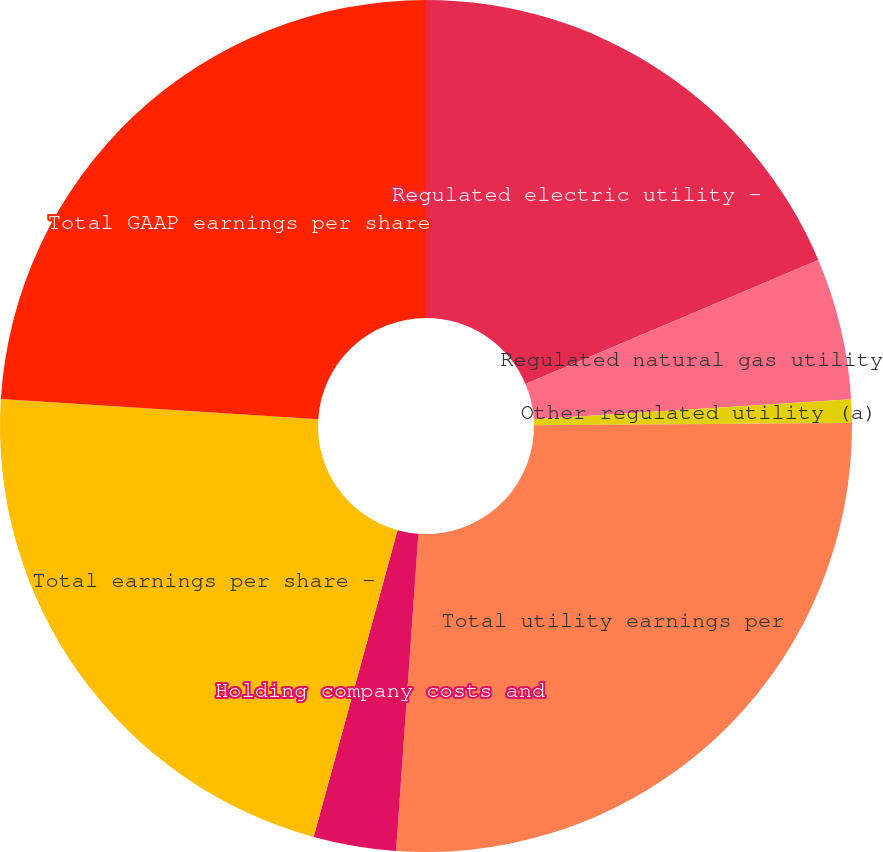Convert chart. <chart><loc_0><loc_0><loc_500><loc_500><pie_chart><fcel>Regulated electric utility -<fcel>Regulated natural gas utility<fcel>Other regulated utility (a)<fcel>Total utility earnings per<fcel>Holding company costs and<fcel>Total earnings per share -<fcel>Total GAAP earnings per share<nl><fcel>18.63%<fcel>5.37%<fcel>0.89%<fcel>26.23%<fcel>3.13%<fcel>21.76%<fcel>23.99%<nl></chart> 